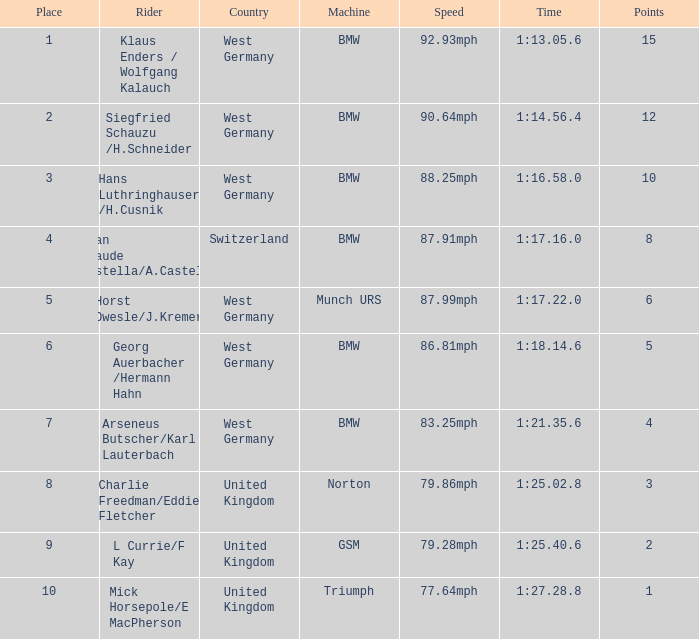In which locations are the points greater than 10? None. 